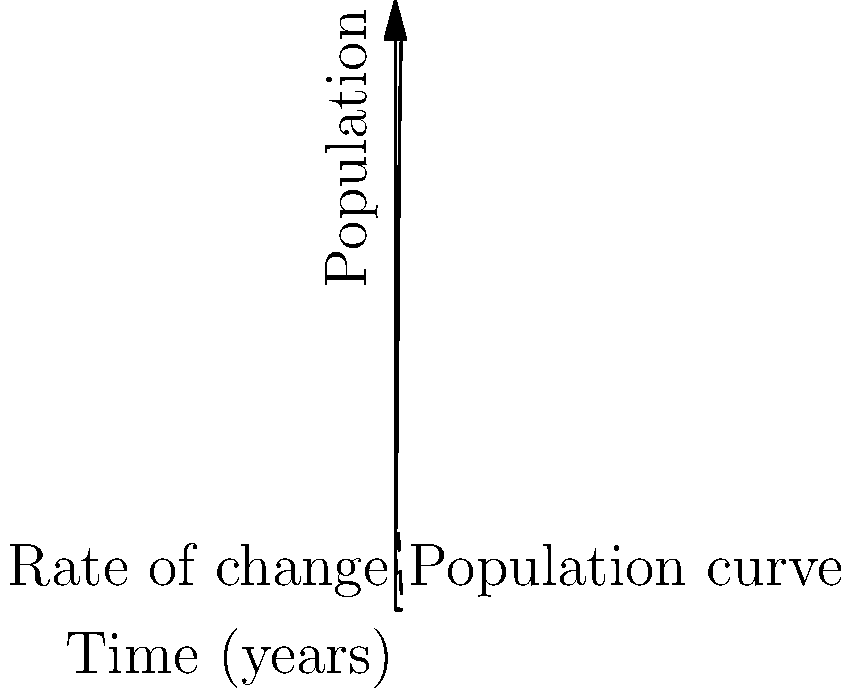In a refugee camp, the population growth follows a logistic curve as shown in the graph. The solid line represents the population over time, while the dashed line shows the rate of change. The population function is given by $P(t) = \frac{1000}{1+9e^{-0.5t}}$, where $t$ is time in years. At what time does the population growth rate reach its maximum value? To find the time when the population growth rate is at its maximum, we need to follow these steps:

1) The rate of change of the population is given by the derivative of $P(t)$:

   $P'(t) = \frac{1000(0.5)(9e^{-0.5t})}{(1+9e^{-0.5t})^2} = \frac{4500e^{-0.5t}}{(1+9e^{-0.5t})^2}$

2) To find the maximum of $P'(t)$, we need to find where its derivative equals zero:

   $P''(t) = \frac{4500e^{-0.5t}(-0.5)(1+9e^{-0.5t})^2 - 4500e^{-0.5t}(2)(1+9e^{-0.5t})(-4.5e^{-0.5t})}{(1+9e^{-0.5t})^4} = 0$

3) Simplifying this equation:

   $-0.5(1+9e^{-0.5t})^2 + 9e^{-0.5t}(1+9e^{-0.5t}) = 0$
   $-0.5 - 9e^{-0.5t} - 40.5e^{-t} + 9e^{-0.5t} + 81e^{-t} = 0$
   $-0.5 + 40.5e^{-t} = 0$
   $40.5e^{-t} = 0.5$
   $e^{-t} = \frac{1}{81}$

4) Taking the natural log of both sides:

   $-t = \ln(\frac{1}{81})$
   $t = \ln(81) = 4.39$ years

5) We can confirm this is a maximum by checking the sign of $P''(t)$ before and after this point.
Answer: 4.39 years 